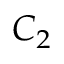<formula> <loc_0><loc_0><loc_500><loc_500>C _ { 2 }</formula> 